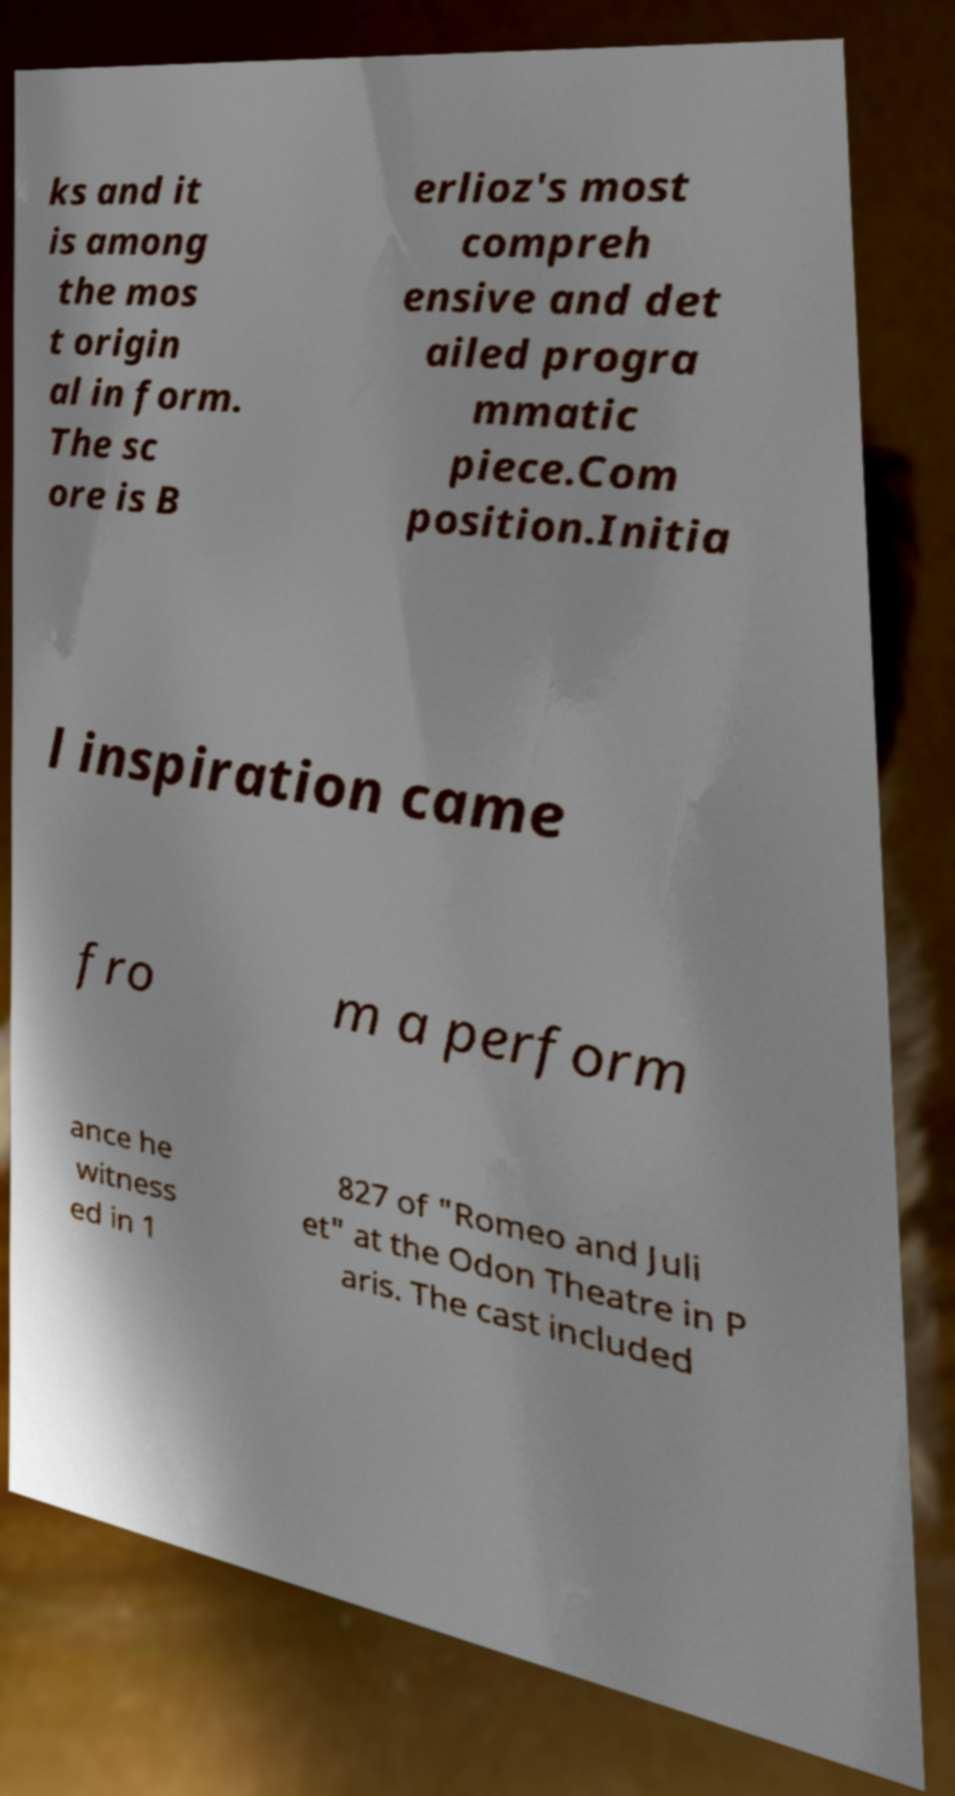Please identify and transcribe the text found in this image. ks and it is among the mos t origin al in form. The sc ore is B erlioz's most compreh ensive and det ailed progra mmatic piece.Com position.Initia l inspiration came fro m a perform ance he witness ed in 1 827 of "Romeo and Juli et" at the Odon Theatre in P aris. The cast included 